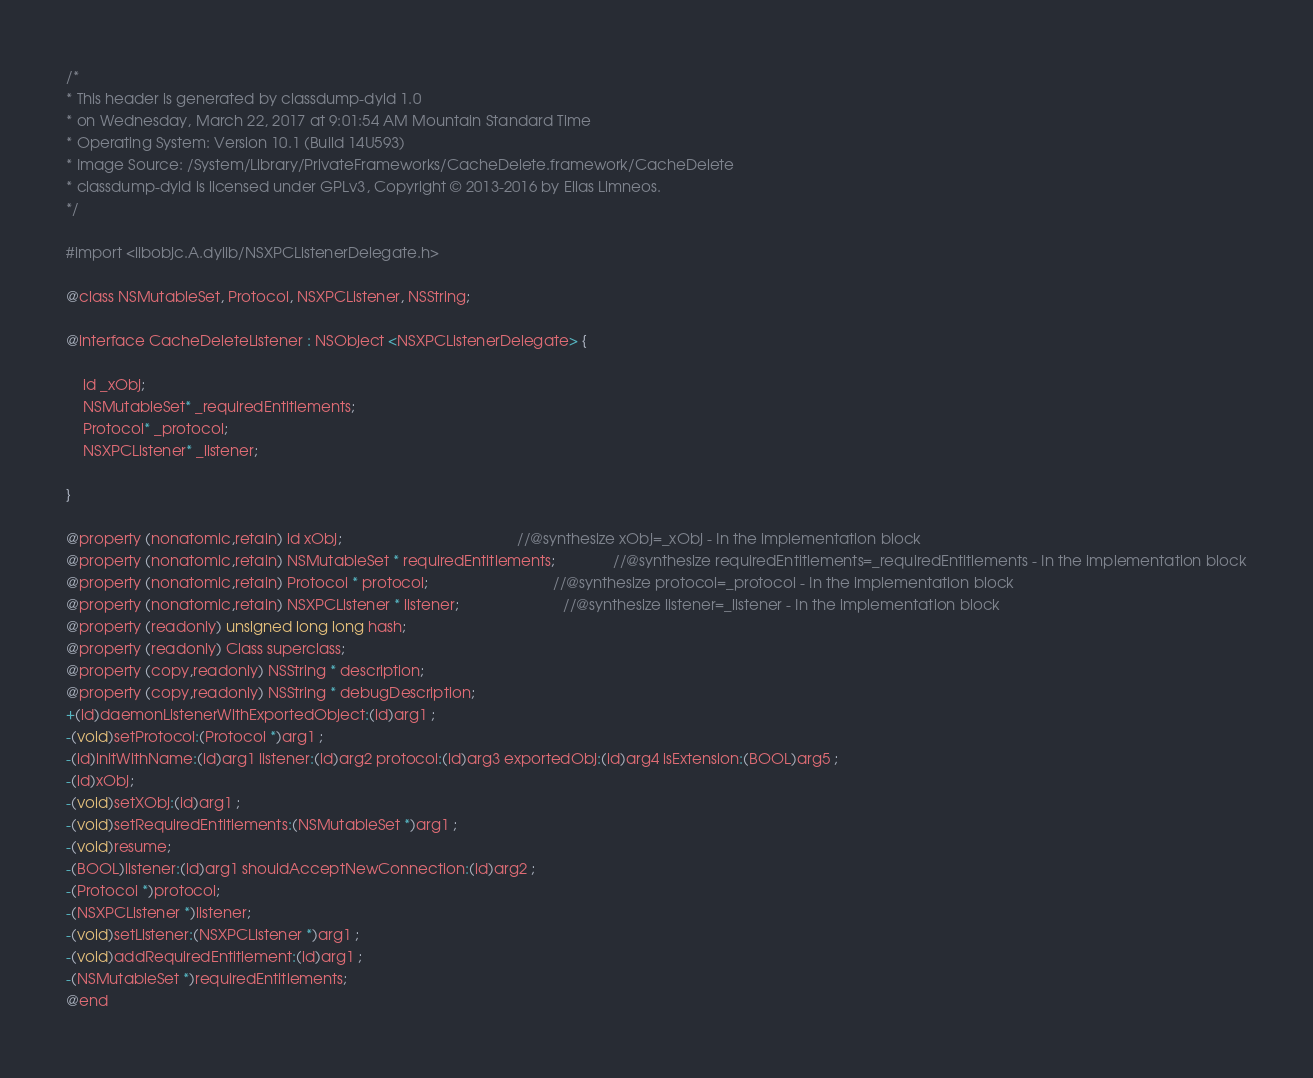<code> <loc_0><loc_0><loc_500><loc_500><_C_>/*
* This header is generated by classdump-dyld 1.0
* on Wednesday, March 22, 2017 at 9:01:54 AM Mountain Standard Time
* Operating System: Version 10.1 (Build 14U593)
* Image Source: /System/Library/PrivateFrameworks/CacheDelete.framework/CacheDelete
* classdump-dyld is licensed under GPLv3, Copyright © 2013-2016 by Elias Limneos.
*/

#import <libobjc.A.dylib/NSXPCListenerDelegate.h>

@class NSMutableSet, Protocol, NSXPCListener, NSString;

@interface CacheDeleteListener : NSObject <NSXPCListenerDelegate> {

	id _xObj;
	NSMutableSet* _requiredEntitlements;
	Protocol* _protocol;
	NSXPCListener* _listener;

}

@property (nonatomic,retain) id xObj;                                          //@synthesize xObj=_xObj - In the implementation block
@property (nonatomic,retain) NSMutableSet * requiredEntitlements;              //@synthesize requiredEntitlements=_requiredEntitlements - In the implementation block
@property (nonatomic,retain) Protocol * protocol;                              //@synthesize protocol=_protocol - In the implementation block
@property (nonatomic,retain) NSXPCListener * listener;                         //@synthesize listener=_listener - In the implementation block
@property (readonly) unsigned long long hash; 
@property (readonly) Class superclass; 
@property (copy,readonly) NSString * description; 
@property (copy,readonly) NSString * debugDescription; 
+(id)daemonListenerWithExportedObject:(id)arg1 ;
-(void)setProtocol:(Protocol *)arg1 ;
-(id)initWithName:(id)arg1 listener:(id)arg2 protocol:(id)arg3 exportedObj:(id)arg4 isExtension:(BOOL)arg5 ;
-(id)xObj;
-(void)setXObj:(id)arg1 ;
-(void)setRequiredEntitlements:(NSMutableSet *)arg1 ;
-(void)resume;
-(BOOL)listener:(id)arg1 shouldAcceptNewConnection:(id)arg2 ;
-(Protocol *)protocol;
-(NSXPCListener *)listener;
-(void)setListener:(NSXPCListener *)arg1 ;
-(void)addRequiredEntitlement:(id)arg1 ;
-(NSMutableSet *)requiredEntitlements;
@end

</code> 